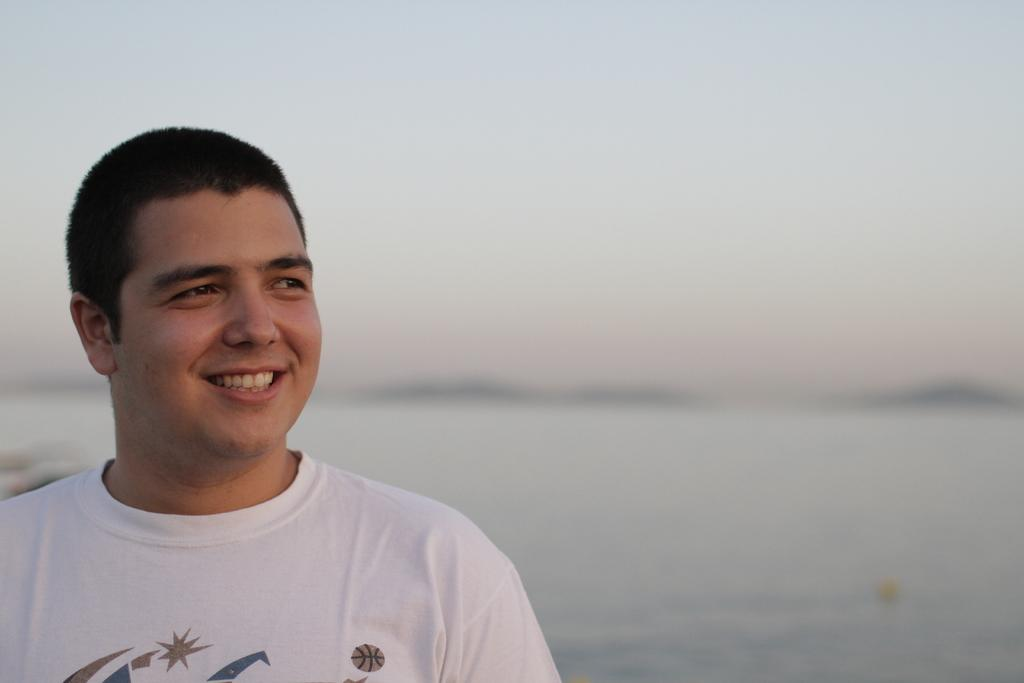Who or what is present in the image? There is a person in the image. What is the person doing or expressing? The person is smiling. What can be seen in the background of the image? There is an ocean in the background of the image. What type of stem is growing in the field behind the person in the image? There is no field or stem present in the image; it features a person smiling with an ocean in the background. 